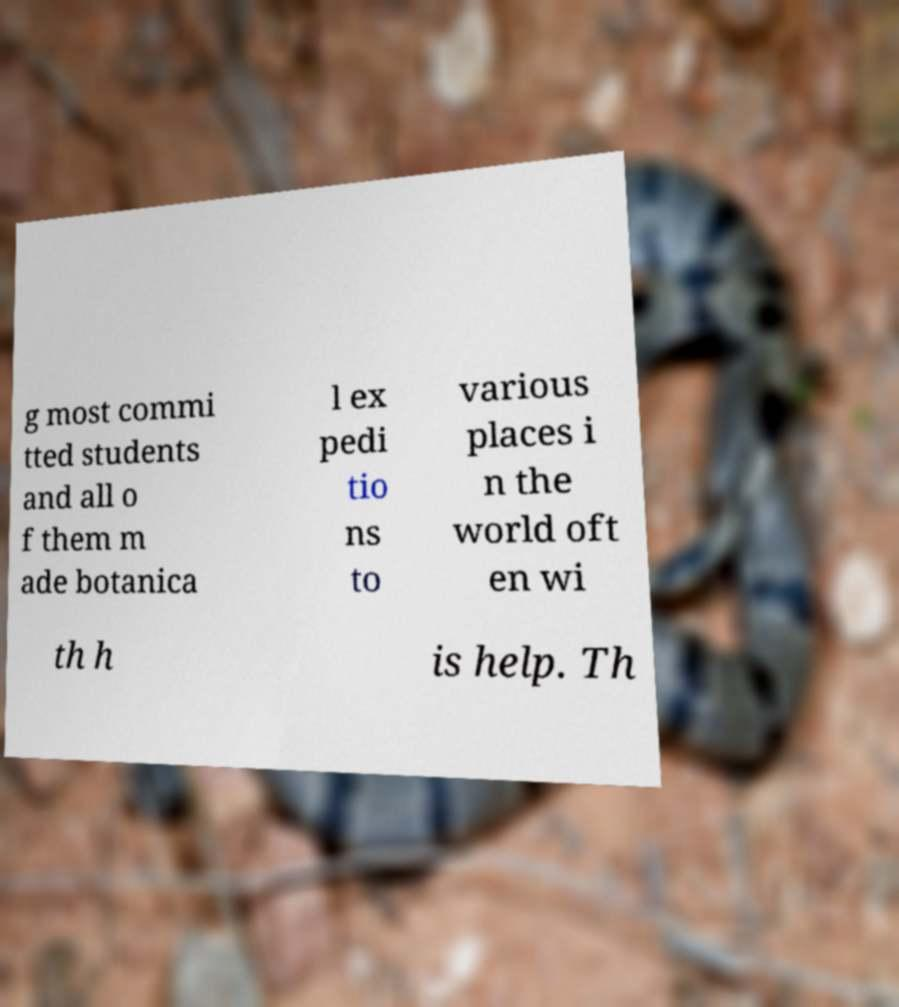Please identify and transcribe the text found in this image. g most commi tted students and all o f them m ade botanica l ex pedi tio ns to various places i n the world oft en wi th h is help. Th 